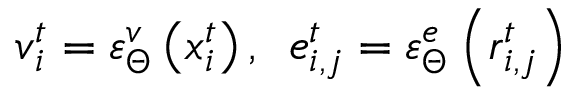Convert formula to latex. <formula><loc_0><loc_0><loc_500><loc_500>v _ { i } ^ { t } = \varepsilon _ { \Theta } ^ { v } \left ( x _ { i } ^ { t } \right ) , \, \ e _ { i , j } ^ { t } = \varepsilon _ { \Theta } ^ { e } \left ( r _ { i , j } ^ { t } \right )</formula> 